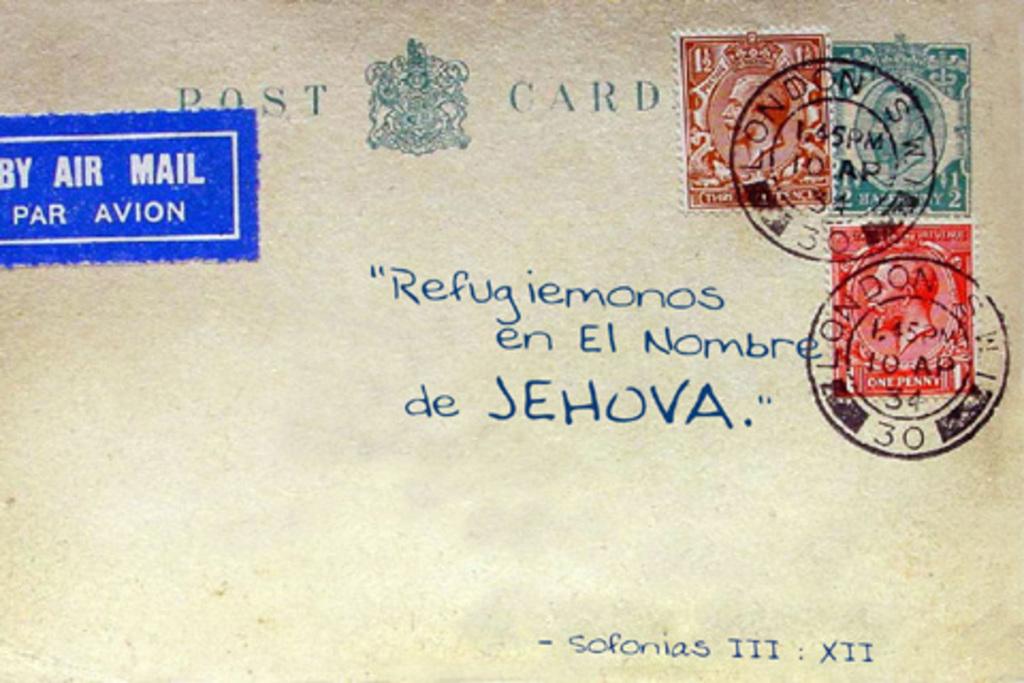What type of mail is this transported with?
Keep it short and to the point. Air mail. What city stamped the envelope?
Keep it short and to the point. London. 